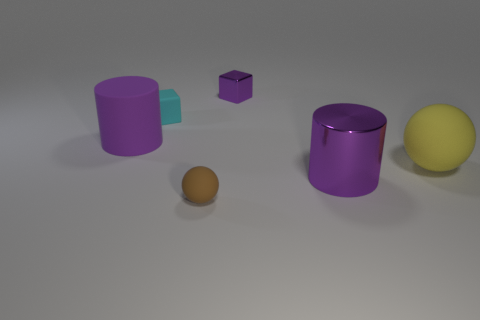Add 2 big balls. How many objects exist? 8 Subtract all blocks. How many objects are left? 4 Add 4 large green blocks. How many large green blocks exist? 4 Subtract 0 green blocks. How many objects are left? 6 Subtract all small matte blocks. Subtract all purple cylinders. How many objects are left? 3 Add 5 brown rubber objects. How many brown rubber objects are left? 6 